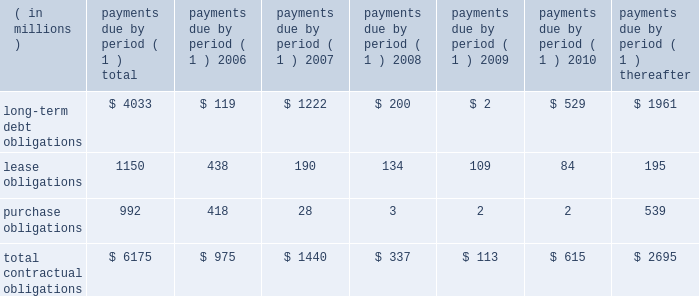57management's discussion and analysis of financial condition and results of operations facility include covenants relating to net interest coverage and total debt-to-book capitalization ratios .
The company was in compliance with the terms of the 3-year credit facility at december 31 , 2005 .
The company has never borrowed under its domestic revolving credit facilities .
Utilization of the non-u.s .
Credit facilities may also be dependent on the company's ability to meet certain conditions at the time a borrowing is requested .
Contractual obligations , guarantees , and other purchase commitments contractual obligations summarized in the table below are the company's obligations and commitments to make future payments under debt obligations ( assuming earliest possible exercise of put rights by holders ) , lease payment obligations , and purchase obligations as of december 31 , 2005 .
Payments due by period ( 1 ) ( in millions ) total 2006 2007 2008 2009 2010 thereafter .
( 1 ) amounts included represent firm , non-cancelable commitments .
Debt obligations : at december 31 , 2005 , the company's long-term debt obligations , including current maturities and unamortized discount and issue costs , totaled $ 4.0 billion , as compared to $ 5.0 billion at december 31 , 2004 .
A table of all outstanding long-term debt securities can be found in note 4 , ""debt and credit facilities'' to the company's consolidated financial statements .
As previously discussed , the decrease in the long- term debt obligations as compared to december 31 , 2004 , was due to the redemptions and repurchases of $ 1.0 billion principal amount of outstanding securities during 2005 .
Also , as previously discussed , the remaining $ 118 million of 7.6% ( 7.6 % ) notes due january 1 , 2007 were reclassified to current maturities of long-term debt .
Lease obligations : the company owns most of its major facilities , but does lease certain office , factory and warehouse space , land , and information technology and other equipment under principally non-cancelable operating leases .
At december 31 , 2005 , future minimum lease obligations , net of minimum sublease rentals , totaled $ 1.2 billion .
Rental expense , net of sublease income , was $ 254 million in 2005 , $ 217 million in 2004 and $ 223 million in 2003 .
Purchase obligations : the company has entered into agreements for the purchase of inventory , license of software , promotional agreements , and research and development agreements which are firm commitments and are not cancelable .
The longest of these agreements extends through 2015 .
Total payments expected to be made under these agreements total $ 992 million .
Commitments under other long-term agreements : the company has entered into certain long-term agreements to purchase software , components , supplies and materials from suppliers .
Most of the agreements extend for periods of one to three years ( three to five years for software ) .
However , generally these agreements do not obligate the company to make any purchases , and many permit the company to terminate the agreement with advance notice ( usually ranging from 60 to 180 days ) .
If the company were to terminate these agreements , it generally would be liable for certain termination charges , typically based on work performed and supplier on-hand inventory and raw materials attributable to canceled orders .
The company's liability would only arise in the event it terminates the agreements for reasons other than ""cause.'' in 2003 , the company entered into outsourcing contracts for certain corporate functions , such as benefit administration and information technology related services .
These contracts generally extend for 10 years and are expected to expire in 2013 .
The total payments under these contracts are approximately $ 3 billion over 10 years ; however , these contracts can be terminated .
Termination would result in a penalty substantially less than the annual contract payments .
The company would also be required to find another source for these services , including the possibility of performing them in-house .
As is customary in bidding for and completing network infrastructure projects and pursuant to a practice the company has followed for many years , the company has a number of performance/bid bonds and standby letters of credit outstanding , primarily relating to projects of government and enterprise mobility solutions segment and the networks segment .
These instruments normally have maturities of up to three years and are standard in the .
What percentage of total contractual obligations are long-term debt obligations? 
Rationale: to figure out this percentage you need to divide long term debt obligations by total contractual obligations .
Computations: (4033 / 6175)
Answer: 0.65312. 